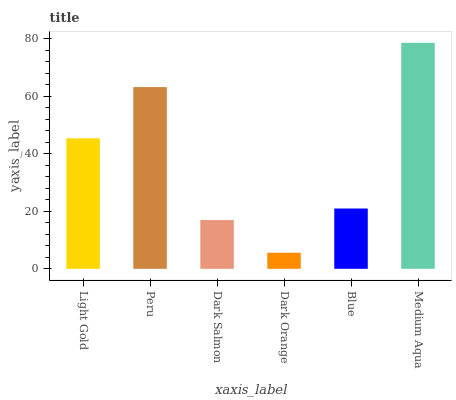Is Dark Orange the minimum?
Answer yes or no. Yes. Is Medium Aqua the maximum?
Answer yes or no. Yes. Is Peru the minimum?
Answer yes or no. No. Is Peru the maximum?
Answer yes or no. No. Is Peru greater than Light Gold?
Answer yes or no. Yes. Is Light Gold less than Peru?
Answer yes or no. Yes. Is Light Gold greater than Peru?
Answer yes or no. No. Is Peru less than Light Gold?
Answer yes or no. No. Is Light Gold the high median?
Answer yes or no. Yes. Is Blue the low median?
Answer yes or no. Yes. Is Blue the high median?
Answer yes or no. No. Is Dark Salmon the low median?
Answer yes or no. No. 